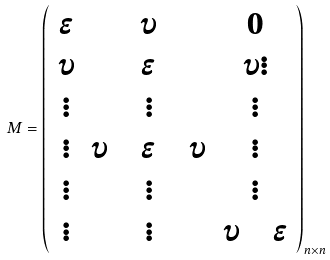<formula> <loc_0><loc_0><loc_500><loc_500>M = \left ( \begin{array} { c c c } \epsilon & \upsilon & 0 \\ \upsilon & \epsilon & \upsilon \vdots \\ \vdots & \vdots & \vdots \\ \vdots & \upsilon \quad \epsilon \quad \upsilon & \vdots \\ \vdots & \vdots & \vdots \\ \vdots & \vdots & \upsilon \quad \epsilon \\ \end{array} \right ) _ { n \times n }</formula> 